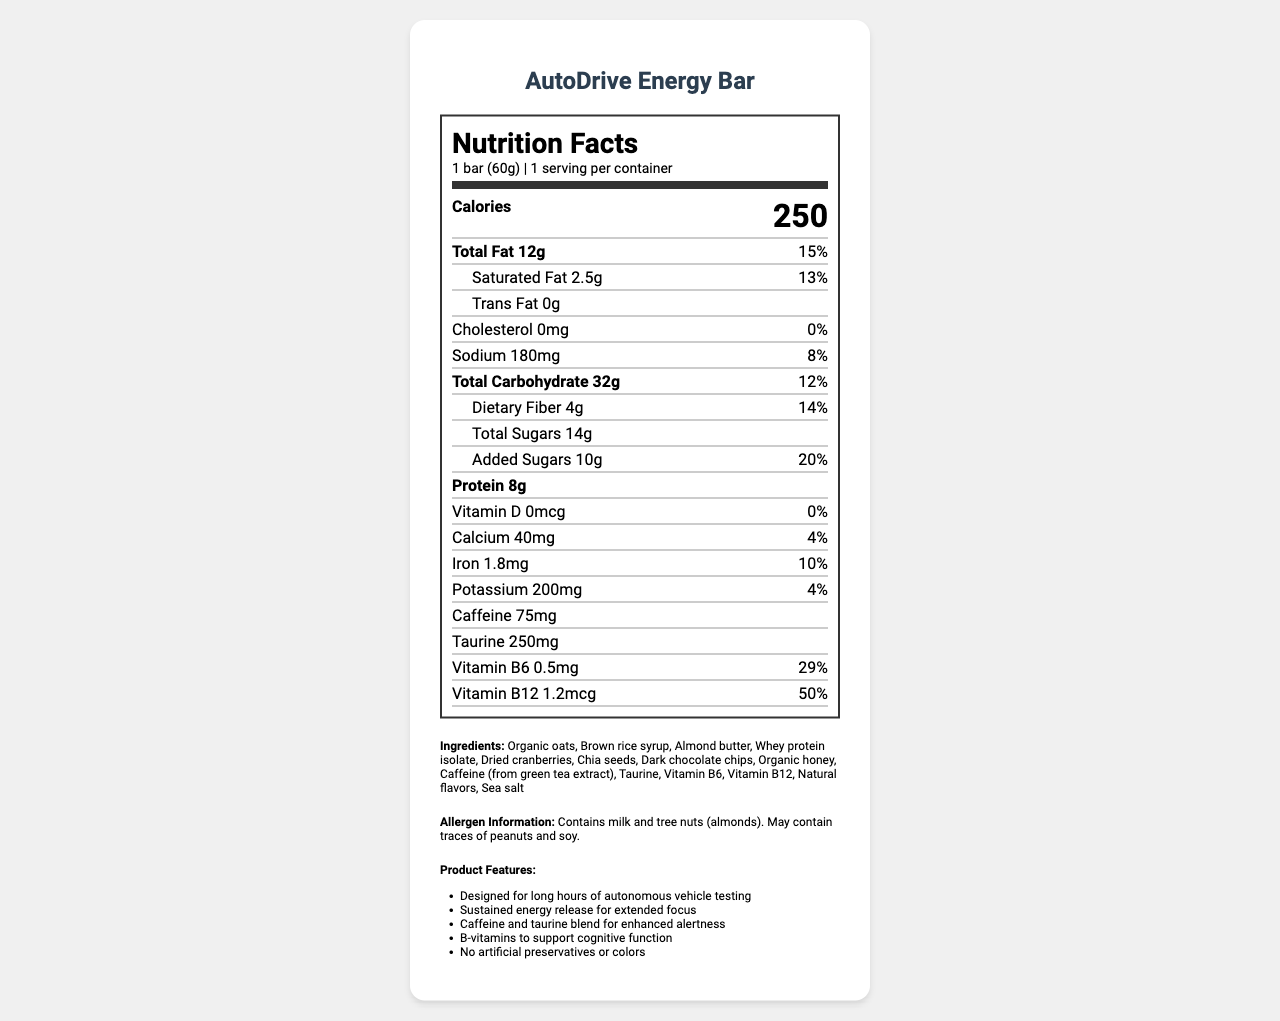What is the serving size of the AutoDrive Energy Bar? The serving size is explicitly listed as "1 bar (60g)" near the top of the Nutrition Facts label.
Answer: 1 bar (60g) How many calories does the AutoDrive Energy Bar contain? The label states the bar contains 250 calories, shown prominently below the serving size.
Answer: 250 What is the amount of protein in the AutoDrive Energy Bar? The amount and daily value percentage of protein is listed in the Nutrition Facts, where it shows 8 grams.
Answer: 8g How much caffeine is in the AutoDrive Energy Bar? The amount of caffeine is listed further down the nutrition label as 75mg.
Answer: 75mg What allergens are present in the AutoDrive Energy Bar? The allergen information is found at the bottom of the label, indicating the bar contains milk and almonds and may contain traces of peanuts and soy.
Answer: Milk and tree nuts (almonds); may contain traces of peanuts and soy What percentage of the daily value for saturated fat does the AutoDrive Energy Bar provide? The saturated fat section states that the bar provides 2.5g which is 13% of the daily value.
Answer: 13% What ingredients are used in the AutoDrive Energy Bar? The ingredients are listed towards the end of the document under the "Ingredients" section.
Answer: Organic oats, Brown rice syrup, Almond butter, Whey protein isolate, Dried cranberries, Chia seeds, Dark chocolate chips, Organic honey, Caffeine (from green tea extract), Taurine, Vitamin B6, Vitamin B12, Natural flavors, Sea salt What claim does the AutoDrive Energy Bar make about its caffeine and taurine content? A. It has a low caffeine content. B. It enhances alertness. C. It promotes relaxation. The marketing claims section includes a claim that the "Caffeine and taurine blend for enhanced alertness."
Answer: B. It enhances alertness. How many grams of dietary fiber does the AutoDrive Energy Bar have? The dietary fiber content is listed as 4 grams in the Nutrition Facts.
Answer: 4g True or False: The AutoDrive Energy bar contains artificial preservatives or colors. One of the marketing claims specifies that the bar has "No artificial preservatives or colors."
Answer: False What is the main purpose of the AutoDrive Energy Bar, according to the marketing claims? The first and primary marketing claim is "Designed for long hours of autonomous vehicle testing."
Answer: Designed for long hours of autonomous vehicle testing Summarize the key features and nutritional information provided in the nutrition label of the AutoDrive Energy Bar. The summary captures the essential nutritional values, purpose, and key ingredients, as well as allergen information and marketing claims of the AutoDrive Energy Bar.
Answer: The AutoDrive Energy Bar is designed to provide sustained energy and enhanced alertness during long hours of autonomous vehicle testing. Each 60g bar contains 250 calories, 12g of fat, 32g of carbohydrates, 8g of protein, 75mg of caffeine, and 250mg of taurine. It also includes B-vitamins to support cognitive function and does not have any artificial preservatives or colors. The bar contains allergens such as milk and almonds and may contain traces of peanuts and soy. Does the nutrition label provide information about vitamin A content? The document does not mention vitamin A content anywhere on the Nutrition Facts label.
Answer: Cannot be determined 